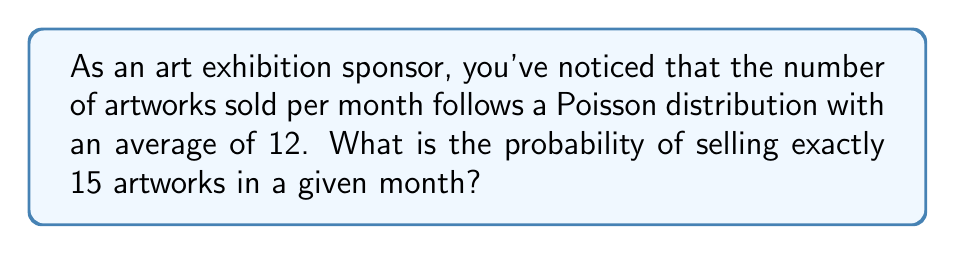What is the answer to this math problem? To solve this problem, we'll use the Poisson probability mass function:

$$P(X = k) = \frac{e^{-\lambda} \lambda^k}{k!}$$

Where:
$\lambda$ = average number of events (in this case, artworks sold per month) = 12
$k$ = number of events we're interested in = 15
$e$ = Euler's number ≈ 2.71828

Step 1: Substitute the values into the formula
$$P(X = 15) = \frac{e^{-12} 12^{15}}{15!}$$

Step 2: Calculate $e^{-12}$
$$e^{-12} \approx 6.14421 \times 10^{-6}$$

Step 3: Calculate $12^{15}$
$$12^{15} = 1.29746 \times 10^{16}$$

Step 4: Calculate 15!
$$15! = 1,307,674,368,000$$

Step 5: Combine the calculations
$$P(X = 15) = \frac{(6.14421 \times 10^{-6})(1.29746 \times 10^{16})}{1,307,674,368,000}$$

Step 6: Simplify
$$P(X = 15) \approx 0.0608$$

Therefore, the probability of selling exactly 15 artworks in a given month is approximately 0.0608 or 6.08%.
Answer: 0.0608 